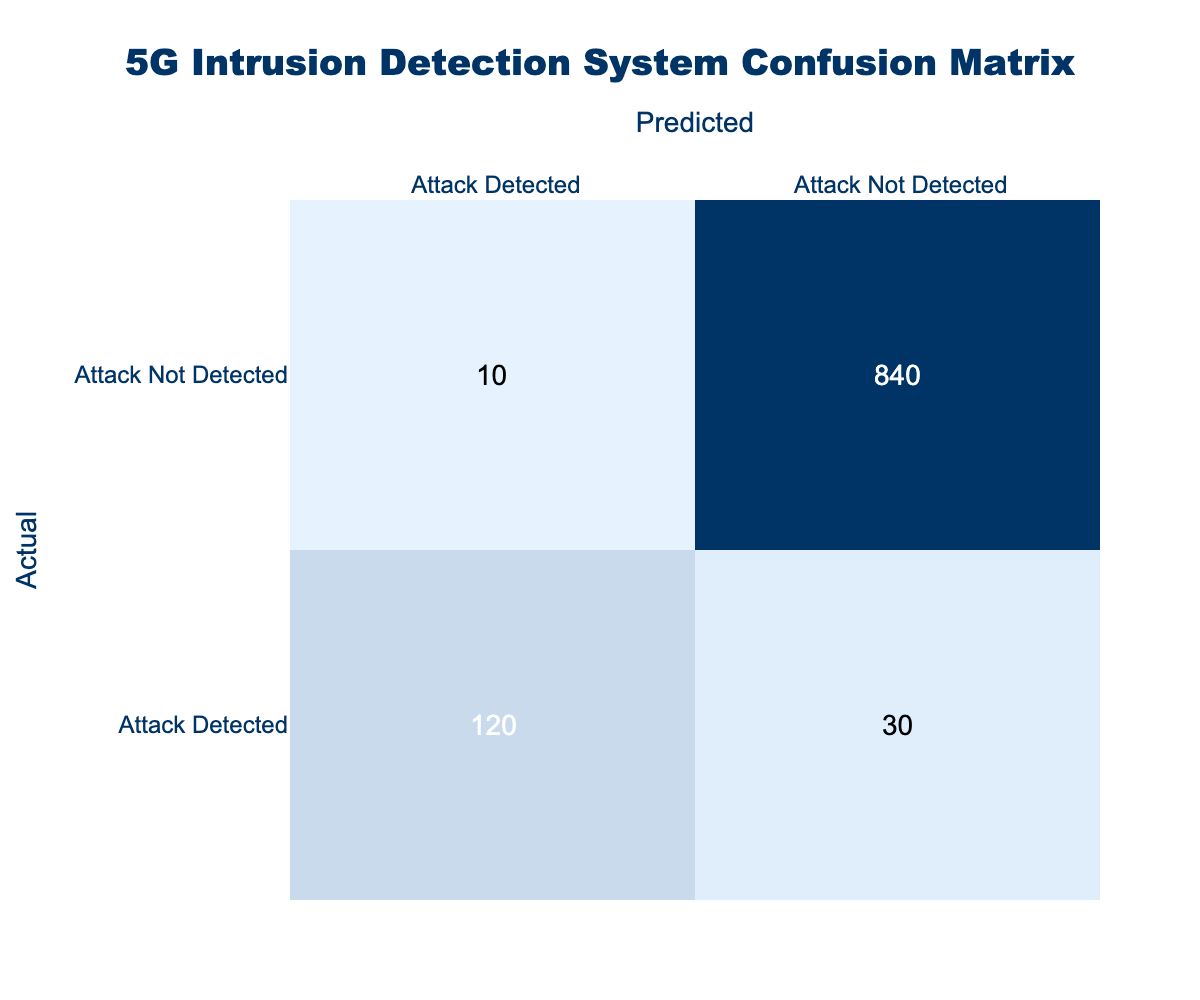What is the number of true positives identified by the system? True positives refer to the instances where the system correctly detects an attack. From the table, this is represented as the cell for "Attack Detected" in the "Attack Detected" row, which shows the value 120.
Answer: 120 How many instances did the system falsely detect an attack when there was none? False positives are indicated by the cell for "Attack Not Detected" in the "Attack Detected" row. The value is 10, meaning these are the cases where the system incorrectly flagged normal traffic as an attack.
Answer: 10 What is the total number of attacks detected by the system? The total number of detected attacks can be calculated by adding the true positives and false negatives. True positives (120) are added to false negatives (30), resulting in 120 + 30 = 150.
Answer: 150 What is the false negative rate of the system? The false negative rate is calculated as the number of false negatives divided by the total number of actual attacks. From the table, false negatives are 30, and the total actual attacks (true positives + false negatives) is 150. Thus, the false negative rate is 30/150 = 0.2, or 20%.
Answer: 20% Is the number of true negatives greater than the number of false positives? True negatives are those instances where the system correctly identifies no attack, which corresponds to the cell for "Attack Not Detected" in the "Attack Not Detected" row (value 840). False positives are 10. Since 840 is greater than 10, the statement is true.
Answer: Yes What is the overall accuracy of the system? Overall accuracy is calculated by taking the number of true positives and true negatives divided by the total number of all predictions made. We can sum true positives (120) and true negatives (840), giving 960. The total predictions are 120 + 30 + 10 + 840 = 1000. Therefore, accuracy = 960/1000 = 0.96, or 96%.
Answer: 96% What is the total number of predicted attacks made by the system? The total number of predicted attacks includes both true positives and false positives. From the table, true positives are 120 and false positives are 10. By adding these values together, we get 120 + 10 = 130.
Answer: 130 What is the difference between true positives and false negatives in this confusion matrix? The difference between true positives (120) and false negatives (30) can be calculated by subtracting the false negatives from the true positives. This gives us 120 - 30 = 90.
Answer: 90 What proportion of detected attacks were true positives? To find the proportion of detected attacks that were true positives, divide the number of true positives (120) by the total detected attacks (150, which includes both true positives and false negatives). Thus, the proportion is 120/150 = 0.8 or 80%.
Answer: 80% 